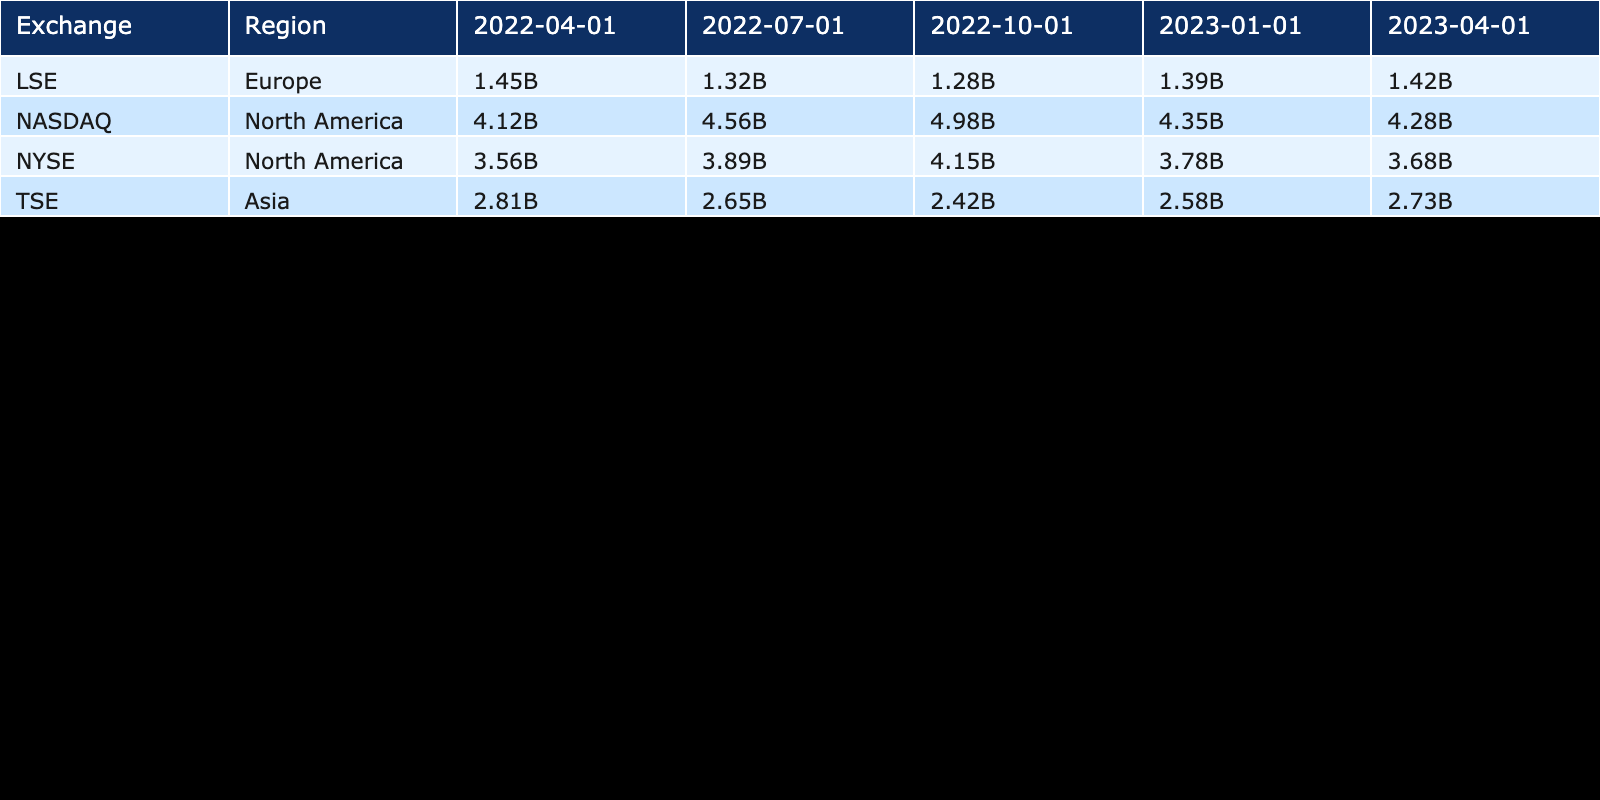What was the trading volume for NASDAQ on April 1, 2022? The table indicates that the trading volume for NASDAQ on April 1, 2022, is listed directly under the respective date, which shows a volume of 4,120,000,000.
Answer: 4.12B What is the trading volume for LSE on October 1, 2022? By consulting the table, we can see the specific value for LSE on October 1, 2022, which states the trading volume as 1,280,000,000.
Answer: 1.28B What is the total trading volume for TSE across all recorded dates? To find the total trading volume for TSE, we sum the volumes: 2,810,000,000 (April) + 2,650,000,000 (July) + 2,420,000,000 (October) + 2,580,000,000 (January 2023) + 2,730,000,000 (April 2023), giving a total of 13,190,000,000.
Answer: 13.19B Is the trading volume for NYSE greater than that of LSE for all dates recorded? By comparing the trading volumes for both exchanges across all dates provided in the table, we find that NYSE has a higher trading volume on April 1, July 1, October 1, 2022, and January 1, 2023, but on April 1, 2023, NYSE is lower than LSE. Thus, the answer is no.
Answer: No What was the average trading volume for the NASDAQ over the given dates? The volumes for NASDAQ are: 4,120,000,000 (April 2022) + 4,560,000,000 (July) + 4,980,000,000 (October) + 4,350,000,000 (January 2023) + 4,280,000,000 (April 2023) = 22,290,000,000. Dividing by the number of recorded dates (5) gives 4,458,000,000 as the average.
Answer: 4.46B Which exchange had the highest trading volume on July 1, 2022? From the table, we observe that on July 1, 2022, NASDAQ had a trading volume of 4,560,000,000, which is higher than the volumes for NYSE (3,890,000,000), LSE (1,320,000,000), and TSE (2,650,000,000). Therefore, the answer is NASDAQ.
Answer: NASDAQ 